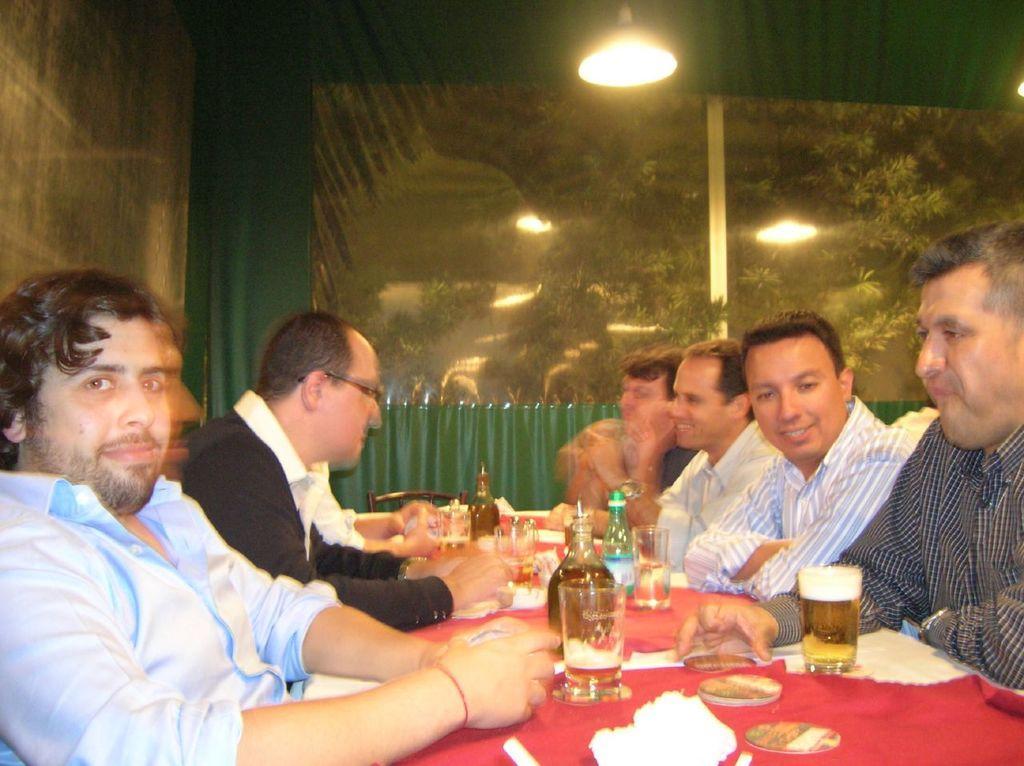In one or two sentences, can you explain what this image depicts? Few men are sitting on the chair. On the table we can see food items,glasses,wine bottles,water bottle. Behind them we can see trees,sky,light. 